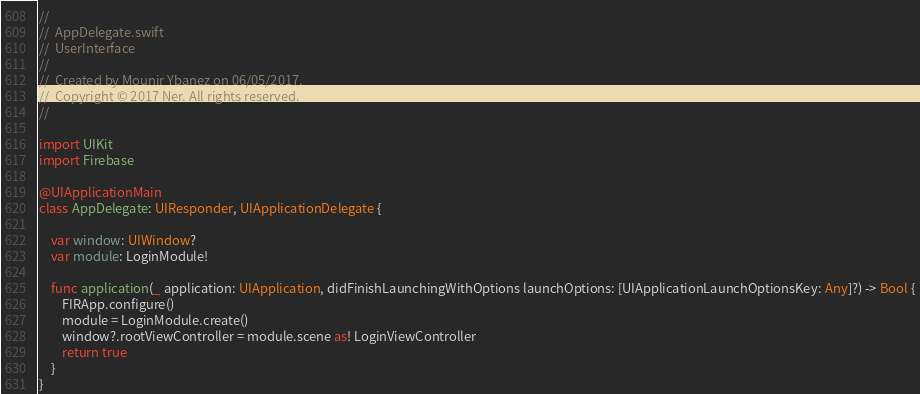Convert code to text. <code><loc_0><loc_0><loc_500><loc_500><_Swift_>//
//  AppDelegate.swift
//  UserInterface
//
//  Created by Mounir Ybanez on 06/05/2017.
//  Copyright © 2017 Ner. All rights reserved.
//

import UIKit
import Firebase

@UIApplicationMain
class AppDelegate: UIResponder, UIApplicationDelegate {

    var window: UIWindow?
    var module: LoginModule!
    
    func application(_ application: UIApplication, didFinishLaunchingWithOptions launchOptions: [UIApplicationLaunchOptionsKey: Any]?) -> Bool {
        FIRApp.configure()
        module = LoginModule.create()
        window?.rootViewController = module.scene as! LoginViewController
        return true
    }
}

</code> 